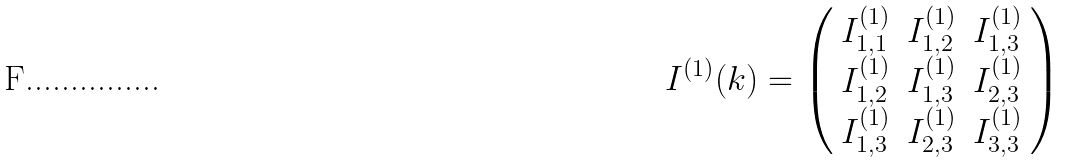Convert formula to latex. <formula><loc_0><loc_0><loc_500><loc_500>I ^ { ( 1 ) } ( k ) = \left ( \begin{array} { c c c } I _ { 1 , 1 } ^ { ( 1 ) } & I _ { 1 , 2 } ^ { ( 1 ) } & I _ { 1 , 3 } ^ { ( 1 ) } \\ I _ { 1 , 2 } ^ { ( 1 ) } & I _ { 1 , 3 } ^ { ( 1 ) } & I _ { 2 , 3 } ^ { ( 1 ) } \\ I _ { 1 , 3 } ^ { ( 1 ) } & I _ { 2 , 3 } ^ { ( 1 ) } & I _ { 3 , 3 } ^ { ( 1 ) } \end{array} \right )</formula> 